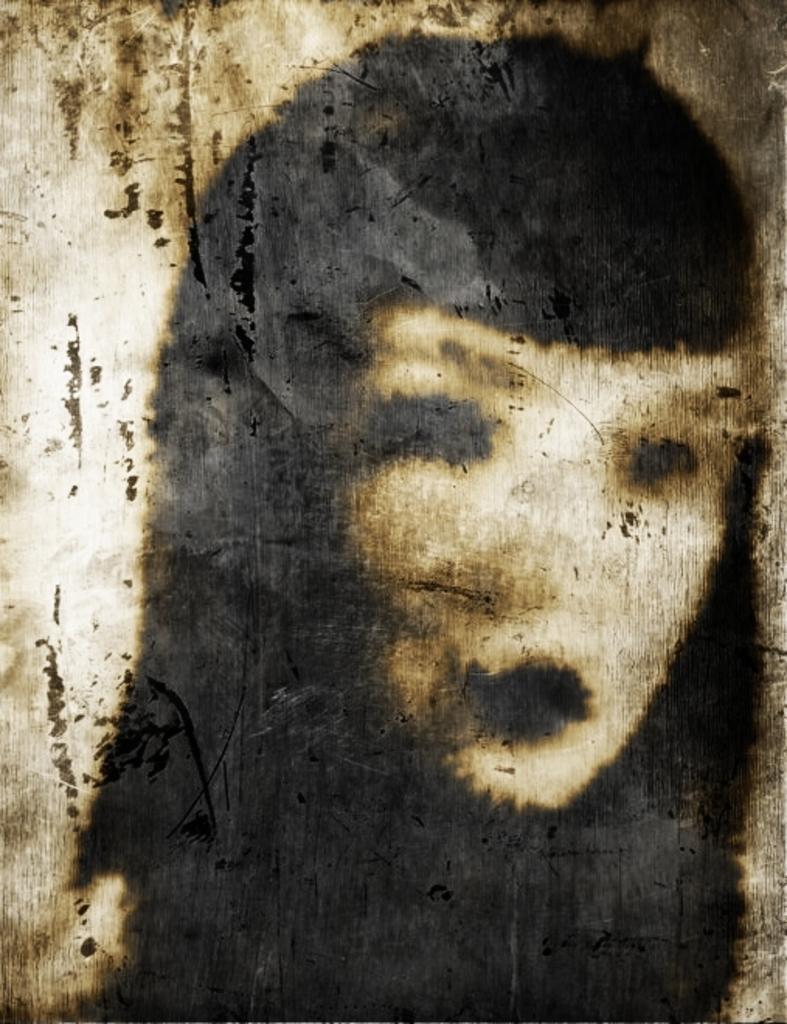In one or two sentences, can you explain what this image depicts? In this picture there is a girls poster in the center of the image. 